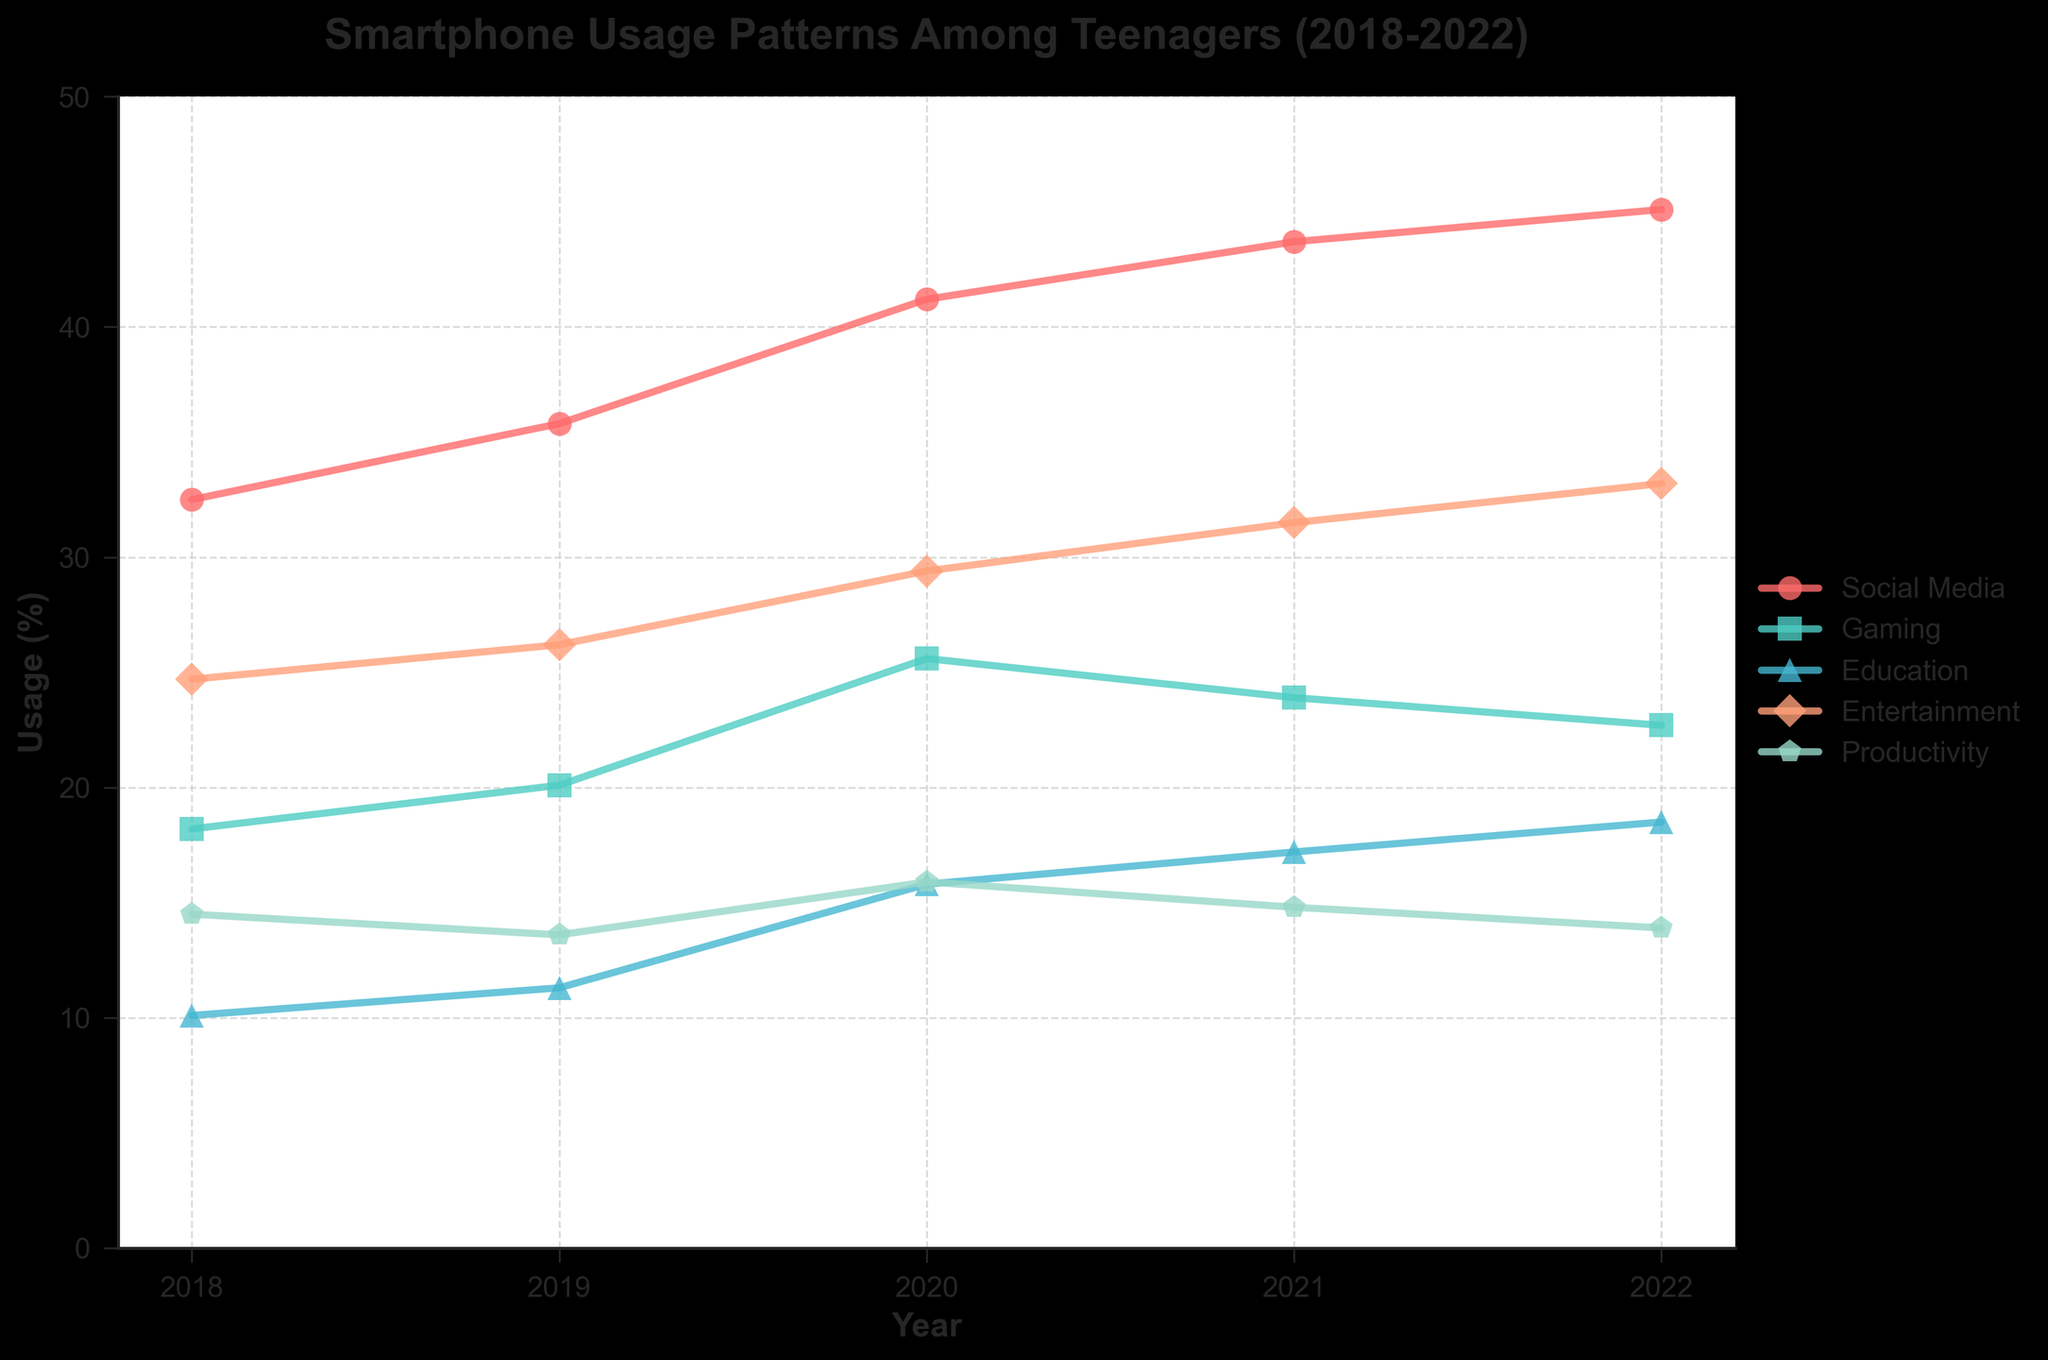What's the trend for Social Media usage from 2018 to 2022? The plot shows that Social Media usage gradually increases each year from 32.5% in 2018 to 45.1% in 2022. This indicates a steady upward trend.
Answer: Upward Which app category had the highest usage percentage in 2022? In 2022, the app category with the highest usage percentage is Social Media with 45.1%.
Answer: Social Media Between which years did Gaming usage experience the largest decrease? To determine the largest decrease, compare the drop between consecutive years for Gaming. The largest decrease occurred between 2020 (25.6%) and 2021 (23.9%), which is a drop of 1.7%.
Answer: 2020 to 2021 How does the usage pattern of Gaming compare with Productivity over the 5-year period? Gaming usage starts at 18.2% in 2018 and peaks at 25.6% in 2020 before declining to 22.7% in 2022. Productivity starts at 14.5% in 2018 and decreases to 13.9% by 2022. Overall, Gaming has higher usage but more fluctuation compared to Productivity.
Answer: Gaming generally higher, more fluctuating What is the average yearly increase in Education app usage from 2018 to 2022? Calculate increases year-over-year for Education: 2019-2018: 1.2%, 2020-2019: 4.5%, 2021-2020: 1.4%, 2022-2021: 1.3%. The average increase is (1.2 + 4.5 + 1.4 + 1.3) / 4 = 2.1% per year.
Answer: 2.1% In 2021, which app categories had higher usage than Productivity? In 2021, the usage percentages are: Social Media (43.7%), Gaming (23.9%), Education (17.2%), Entertainment (31.5%), Productivity (14.8%). Comparatively, Social Media, Gaming, Education, and Entertainment all had higher usage than Productivity.
Answer: Social Media, Gaming, Education, Entertainment If the trend continues, will Social Media usage exceed 50% in 2023? The yearly increases for Social Media were 2018-2019: 3.3%, 2019-2020: 5.4%, 2020-2021: 2.5%, 2021-2022: 1.4%. Analyzing the rate shows it's decreasing. Even if it maintains the smallest increase (1.4%), usage in 2023 will be 45.1% + 1.4% = 46.5%, below 50%.
Answer: No Which year had the overall highest usage across all categories combined? Sum usage percentages for each year: 2018: 100%, 2019: 107%, 2020: 128%, 2021: 130.1%, 2022: 133.4%. The highest combined usage is in 2022 with 133.4%.
Answer: 2022 